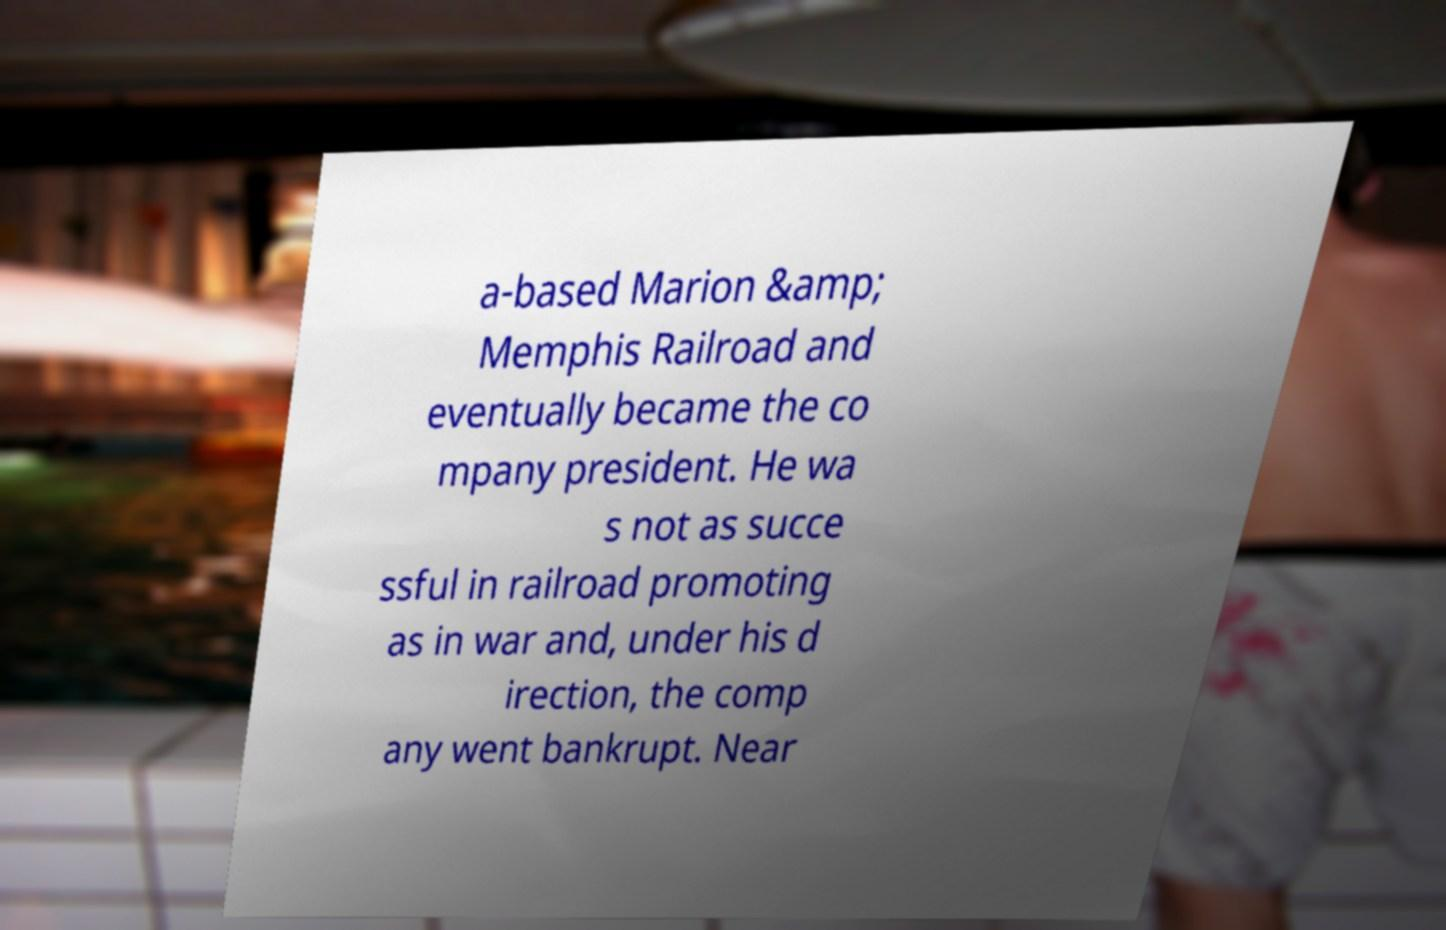There's text embedded in this image that I need extracted. Can you transcribe it verbatim? a-based Marion &amp; Memphis Railroad and eventually became the co mpany president. He wa s not as succe ssful in railroad promoting as in war and, under his d irection, the comp any went bankrupt. Near 